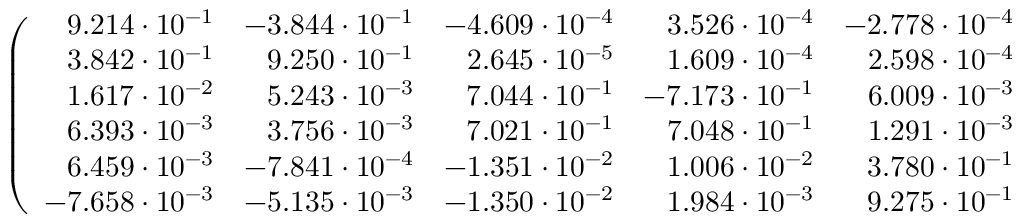<formula> <loc_0><loc_0><loc_500><loc_500>\left ( \begin{array} { r r r r r r } { 9 . 2 1 4 \cdot 1 0 ^ { - 1 } } & { - 3 . 8 4 4 \cdot 1 0 ^ { - 1 } } & { - 4 . 6 0 9 \cdot 1 0 ^ { - 4 } } & { 3 . 5 2 6 \cdot 1 0 ^ { - 4 } } & { - 2 . 7 7 8 \cdot 1 0 ^ { - 4 } } & { 3 . 3 2 4 \cdot 1 0 ^ { - 4 } } \\ { 3 . 8 4 2 \cdot 1 0 ^ { - 1 } } & { 9 . 2 5 0 \cdot 1 0 ^ { - 1 } } & { 2 . 6 4 5 \cdot 1 0 ^ { - 5 } } & { 1 . 6 0 9 \cdot 1 0 ^ { - 4 } } & { 2 . 5 9 8 \cdot 1 0 ^ { - 4 } } & { 7 . 4 9 1 \cdot 1 0 ^ { - 5 } } \\ { 1 . 6 1 7 \cdot 1 0 ^ { - 2 } } & { 5 . 2 4 3 \cdot 1 0 ^ { - 3 } } & { 7 . 0 4 4 \cdot 1 0 ^ { - 1 } } & { - 7 . 1 7 3 \cdot 1 0 ^ { - 1 } } & { 6 . 0 0 9 \cdot 1 0 ^ { - 3 } } & { - 1 . 8 5 1 \cdot 1 0 ^ { - 3 } } \\ { 6 . 3 9 3 \cdot 1 0 ^ { - 3 } } & { 3 . 7 5 6 \cdot 1 0 ^ { - 3 } } & { 7 . 0 2 1 \cdot 1 0 ^ { - 1 } } & { 7 . 0 4 8 \cdot 1 0 ^ { - 1 } } & { 1 . 2 9 1 \cdot 1 0 ^ { - 3 } } & { 1 . 3 4 0 \cdot 1 0 ^ { - 3 } } \\ { 6 . 4 5 9 \cdot 1 0 ^ { - 3 } } & { - 7 . 8 4 1 \cdot 1 0 ^ { - 4 } } & { - 1 . 3 5 1 \cdot 1 0 ^ { - 2 } } & { 1 . 0 0 6 \cdot 1 0 ^ { - 2 } } & { 3 . 7 8 0 \cdot 1 0 ^ { - 1 } } & { - 9 . 2 4 1 \cdot 1 0 ^ { - 1 } } \\ { - 7 . 6 5 8 \cdot 1 0 ^ { - 3 } } & { - 5 . 1 3 5 \cdot 1 0 ^ { - 3 } } & { - 1 . 3 5 0 \cdot 1 0 ^ { - 2 } } & { 1 . 9 8 4 \cdot 1 0 ^ { - 3 } } & { 9 . 2 7 5 \cdot 1 0 ^ { - 1 } } & { 3 . 7 7 7 \cdot 1 0 ^ { - 1 } } \end{array} \right )</formula> 